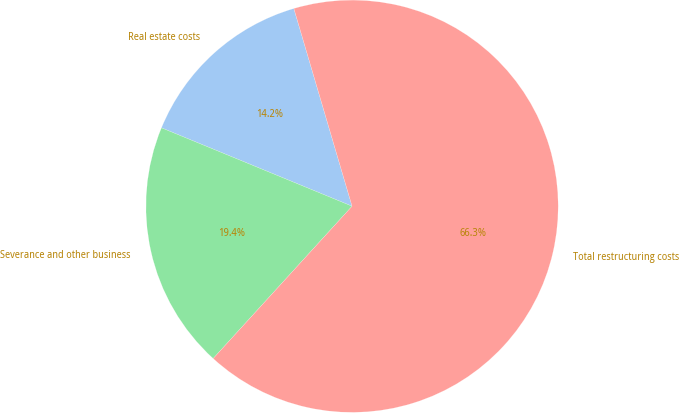Convert chart. <chart><loc_0><loc_0><loc_500><loc_500><pie_chart><fcel>Real estate costs<fcel>Severance and other business<fcel>Total restructuring costs<nl><fcel>14.23%<fcel>19.44%<fcel>66.32%<nl></chart> 